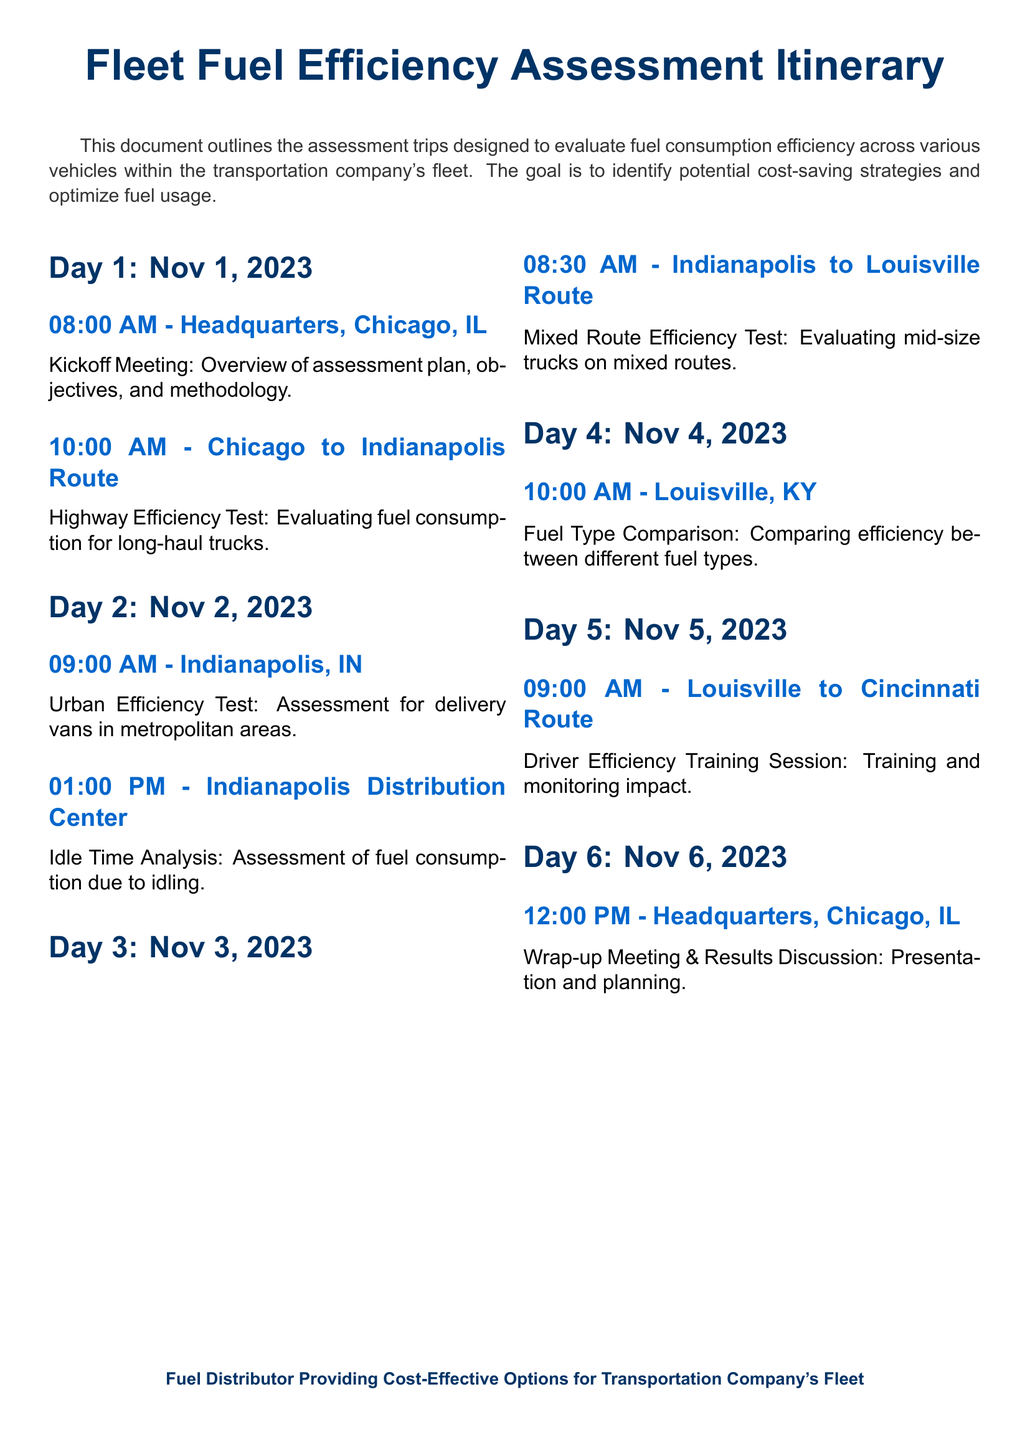what is the title of the document? The title is prominently displayed at the top of the document, identifying its purpose.
Answer: Fleet Fuel Efficiency Assessment Itinerary what is the date of the kickoff meeting? The kickoff meeting date is mentioned at the start of Day 1's schedule.
Answer: Nov 1, 2023 at what time does the wrap-up meeting start? The starting time of the wrap-up meeting is indicated under Day 6's schedule.
Answer: 12:00 PM which route is assessed on Day 3? The specific route being assessed is highlighted in the itinerary for Day 3.
Answer: Indianapolis to Louisville Route how many vehicles are being evaluated in the assessment? The document outlines various vehicles but does not provide a specific count.
Answer: Multiple what is the focus of the assessment on Day 2? Each day's objectives are clearly defined, and Day 2's focus is specified.
Answer: Urban Efficiency Test which city is the headquarters located in? The headquarters location is mentioned at the beginning of Day 1.
Answer: Chicago, IL what type of training session occurs on Day 5? Day 5's session type reflects the overall goal of improving efficiency.
Answer: Driver Efficiency Training Session what is the purpose of the Fuel Type Comparison on Day 4? The objective for Day 4's assessment is to evaluate differences in fuel efficiency.
Answer: Comparing efficiency between different fuel types 